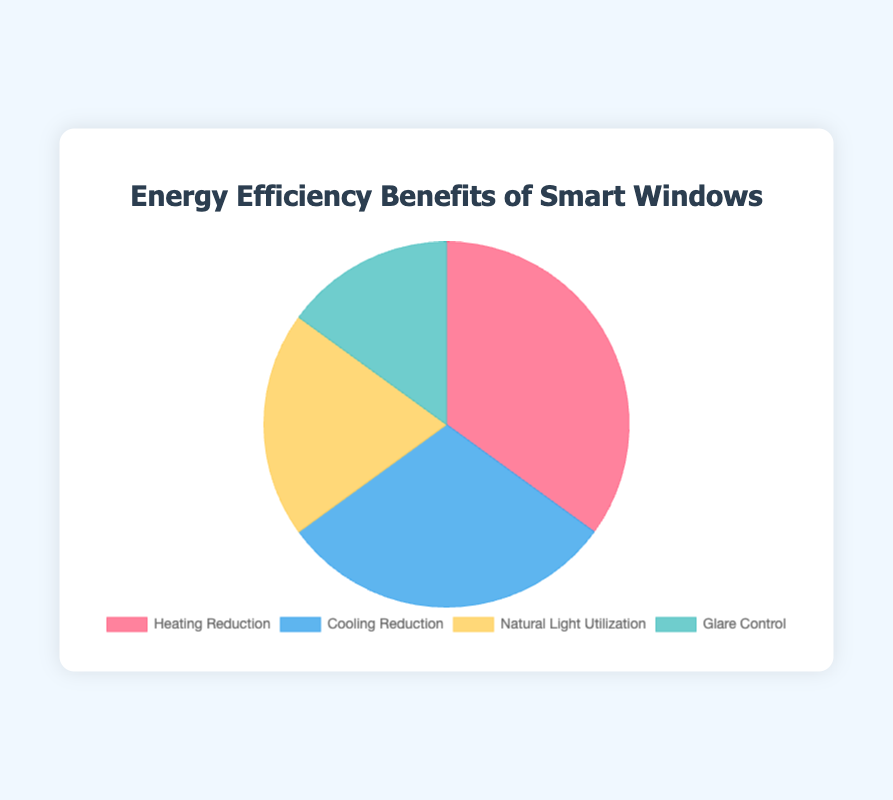What is the largest benefit of smart windows in terms of energy efficiency? The pie chart shows that "Heating Reduction" has the highest percentage at 35%, making it the largest benefit.
Answer: Heating Reduction How much higher is the percentage of heating reduction compared to glare control? Heating Reduction is 35% and Glare Control is 15%, so the difference is 35% - 15% = 20%.
Answer: 20% Which benefit has the lowest percentage in the chart? The pie chart shows that "Glare Control" has the lowest percentage, which is 15%.
Answer: Glare Control What is the combined percentage for Cooling and Heating Reduction? Adding up the percentages for "Cooling Reduction" (30%) and "Heating Reduction" (35%), the combined percentage is 30% + 35% = 65%.
Answer: 65% How many percentage points greater is the Natural Light Utilization compared to Glare Control? Natural Light Utilization is 20% and Glare Control is 15%. The difference is 20% - 15% = 5%.
Answer: 5% Which benefit contributes more, Natural Light Utilization or Cooling Reduction? The pie chart shows that Cooling Reduction contributes 30%, while Natural Light Utilization contributes 20%. So, Cooling Reduction contributes more.
Answer: Cooling Reduction What percentage of the total does Glare Control and Natural Light Utilization represent together? Adding the percentages of Glare Control (15%) and Natural Light Utilization (20%), the total is 15% + 20% = 35%.
Answer: 35% Are heating reduction and cooling reduction benefits almost equal? Comparing the percentages for Heating Reduction (35%) and Cooling Reduction (30%), they are close but not equal.
Answer: No How much smaller is Glare Control compared to Heating Reduction? Heating Reduction is 35% and Glare Control is 15%. The difference is 35% - 15% = 20%.
Answer: 20% If we combine all the benefits except Cooling Reduction, what is the total percentage? Adding up Heating Reduction (35%), Natural Light Utilization (20%), and Glare Control (15%), the total is 35% + 20% + 15% = 70%.
Answer: 70% 